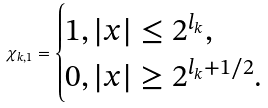Convert formula to latex. <formula><loc_0><loc_0><loc_500><loc_500>\chi _ { k , 1 } = \begin{cases} 1 , | x | \leq 2 ^ { l _ { k } } , \\ 0 , | x | \geq 2 ^ { l _ { k } + 1 / 2 } . \end{cases}</formula> 